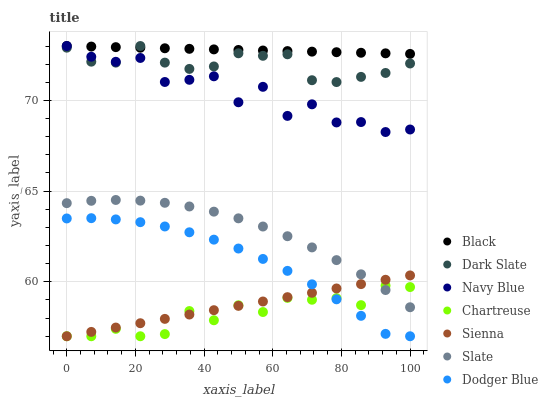Does Chartreuse have the minimum area under the curve?
Answer yes or no. Yes. Does Black have the maximum area under the curve?
Answer yes or no. Yes. Does Slate have the minimum area under the curve?
Answer yes or no. No. Does Slate have the maximum area under the curve?
Answer yes or no. No. Is Sienna the smoothest?
Answer yes or no. Yes. Is Navy Blue the roughest?
Answer yes or no. Yes. Is Slate the smoothest?
Answer yes or no. No. Is Slate the roughest?
Answer yes or no. No. Does Sienna have the lowest value?
Answer yes or no. Yes. Does Slate have the lowest value?
Answer yes or no. No. Does Black have the highest value?
Answer yes or no. Yes. Does Slate have the highest value?
Answer yes or no. No. Is Chartreuse less than Dark Slate?
Answer yes or no. Yes. Is Dark Slate greater than Chartreuse?
Answer yes or no. Yes. Does Chartreuse intersect Slate?
Answer yes or no. Yes. Is Chartreuse less than Slate?
Answer yes or no. No. Is Chartreuse greater than Slate?
Answer yes or no. No. Does Chartreuse intersect Dark Slate?
Answer yes or no. No. 